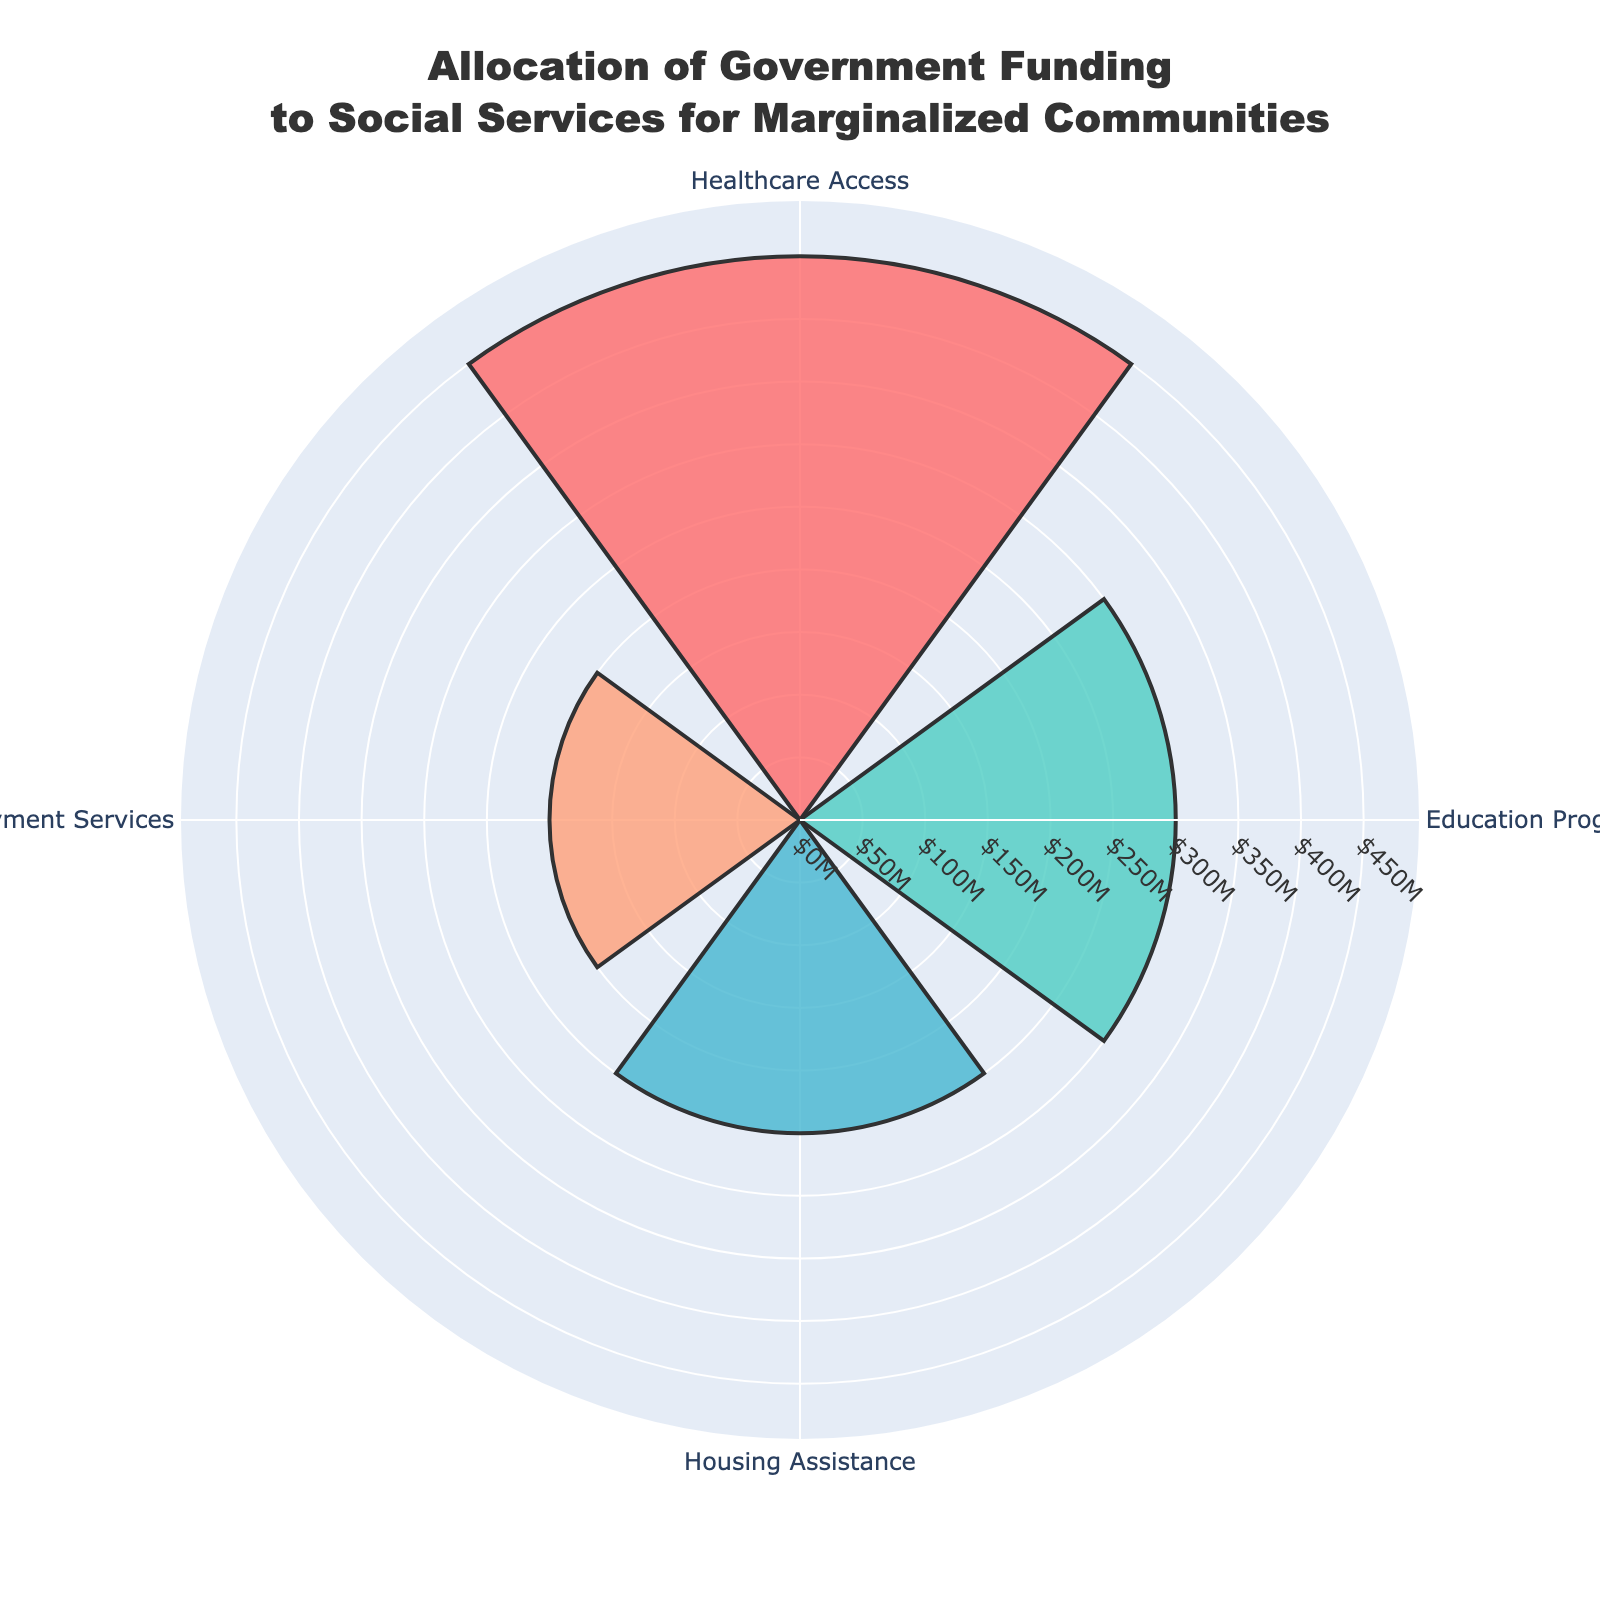Which category receives the highest allocation of funding? The Healthcare Access category has the highest allocation with 450 million dollars, which is visually represented by the longest bar in the rose chart.
Answer: Healthcare Access What is the total amount of funding allocated across all categories? Sum the amounts allocated to each category: 450 million + 300 million + 250 million + 200 million = 1200 million dollars.
Answer: 1200 million How does the funding for Education Programs compare to Employment Services? The allocation for Education Programs is 300 million, while Employment Services is 200 million. By comparing these two amounts, Education Programs have 100 million more allocated than Employment Services.
Answer: Education Programs has 100 million more What percentage of the total funding is allocated to Housing Assistance? First, find the total funding: 450M + 300M + 250M + 200M = 1200M. The percentage is then calculated as (250M/1200M) * 100% = 20.83%.
Answer: 20.83% Which category has the smallest allocation, and what is its amount? The Employment Services category has the smallest allocation with 200 million dollars, which can be seen as the shortest bar in the rose chart.
Answer: Employment Services, 200 million If an additional 50 million was reallocated from Healthcare Access to Housing Assistance, what would the new funding amounts be? Subtract 50 million from Healthcare Access and add it to Housing Assistance: Healthcare Access becomes 450M - 50M = 400M, and Housing Assistance becomes 250M + 50M = 300M.
Answer: Healthcare Access: 400 million, Housing Assistance: 300 million What is the difference in funding between Housing Assistance and Education Programs? The funding for Housing Assistance is 250 million, and for Education Programs, it is 300 million. The difference is 300 million - 250 million = 50 million.
Answer: 50 million Arrange the categories in descending order based on their allocation amounts. The order from the highest to the lowest allocation is: Healthcare Access (450M), Education Programs (300M), Housing Assistance (250M), Employment Services (200M).
Answer: Healthcare Access, Education Programs, Housing Assistance, Employment Services 